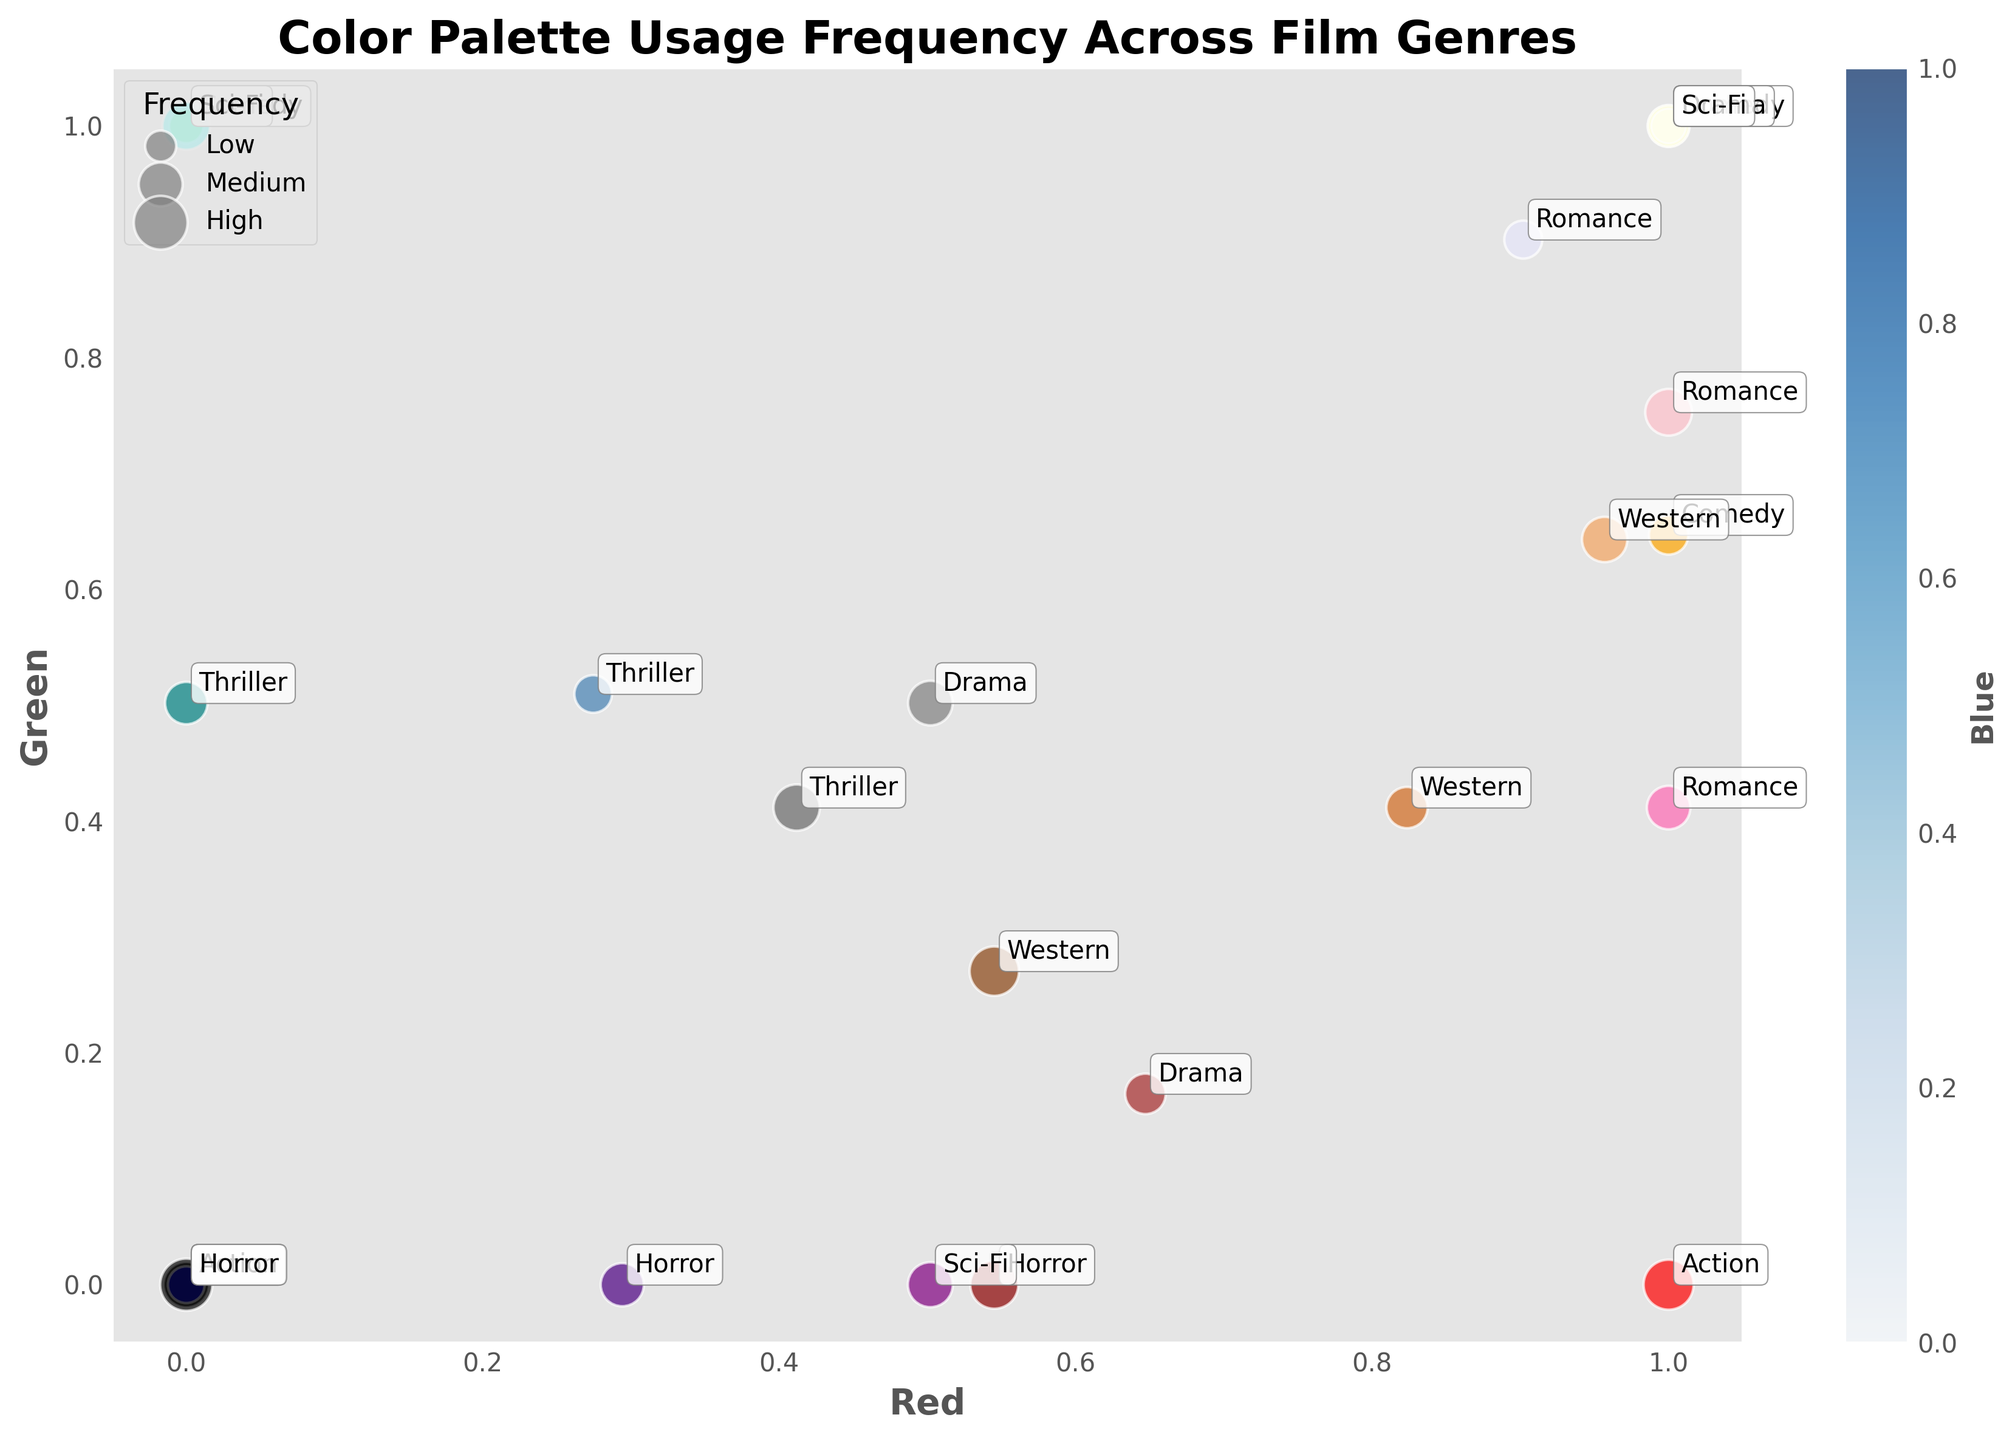What is the title of the figure? The title of the figure is typically located at the top of the chart. In this case, it reads 'Color Palette Usage Frequency Across Film Genres'.
Answer: Color Palette Usage Frequency Across Film Genres Which axis represents the 'Red' color component? Axis labels indicate what each axis represents. The x-axis is labeled 'Red' indicating that it represents the red color component.
Answer: x-axis How many genres are displayed in the figure? Each genre is annotated next to its corresponding data points. Counting each unique genre listed reveals that there are eight genres present: Action, Comedy, Drama, Horror, Romance, Sci-Fi, Western, and Thriller.
Answer: 8 genres What color has the highest frequency in the Horror genre? By looking at the color palette and frequency annotations for the Horror genre, the highest frequency color is #000000 (black), with a frequency of 85.
Answer: #000000 Which film genre uses the color with RGB (0, 255, 0) and what is its frequency? The normalized RGB (0, 255, 0) corresponds to #00FF00 (green). The figure indicates that this color is used in the Comedy genre with a frequency of 37.
Answer: Comedy, 37 Are there any genres that use white (#FFFFFF) more than once? By observing the data points annotated with color information, we can see that the Drama and Sci-Fi genres both have a white (#FFFFFF) color, with frequencies of 39 and 52 respectively.
Answer: Yes, Drama and Sci-Fi Which genre uses the color #FFC0CB (pink), and what is its frequency? The color #FFC0CB (pink) is annotated in the genre Romance with a frequency of 68.
Answer: Romance, 68 Which genre has the most data points, and how many does it have? By counting the annotated data points for each genre, Horror has the most data points with three colors: #000000 (85), #8B0000 (72), and #4B0082 (58).
Answer: Horror, 3 What's the average frequency of colors used in the Action genre? The Action genre's frequencies are 78, 65, and 42. Summing these gives 78 + 65 + 42 = 185. The average is 185 / 3 = 61.67.
Answer: 61.67 Which color component (Red, Green, Blue) is represented by the color bar, and what does it signify? The color bar usually indicates the third color component not directly plotted on the axes. Here, it is labeled 'Blue', showing the blue component's intensity.
Answer: Blue 